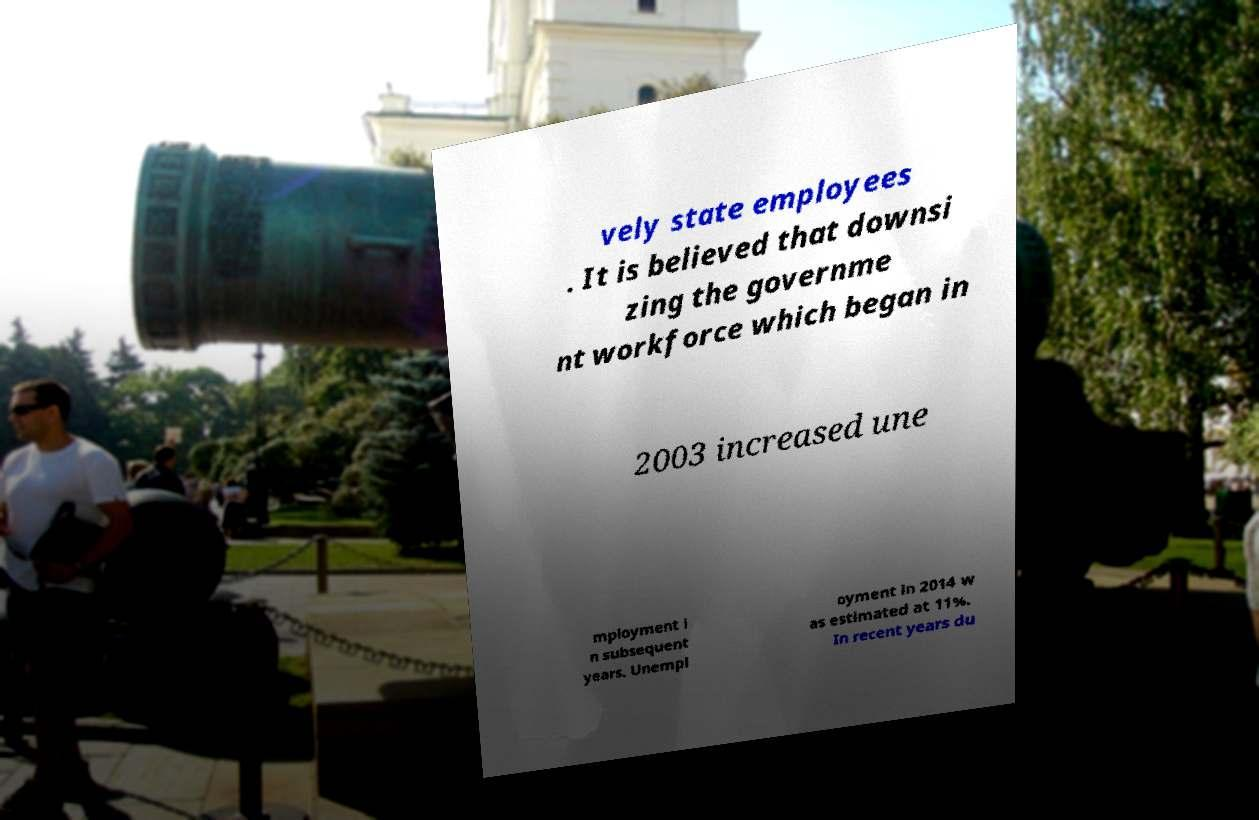Please read and relay the text visible in this image. What does it say? vely state employees . It is believed that downsi zing the governme nt workforce which began in 2003 increased une mployment i n subsequent years. Unempl oyment in 2014 w as estimated at 11%. In recent years du 